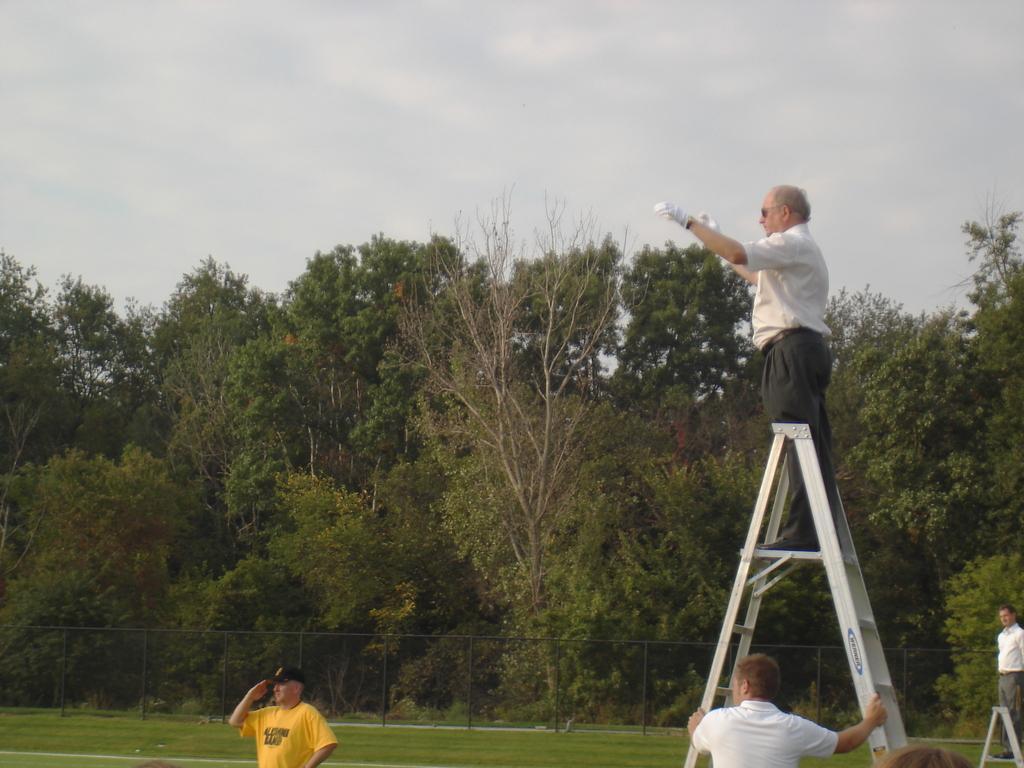Could you give a brief overview of what you see in this image? In the image we can see there are people wearing clothes and some of them are wearing a cap, gloves and goggles. This is a grass, fence, trees and a cloudy sky. 